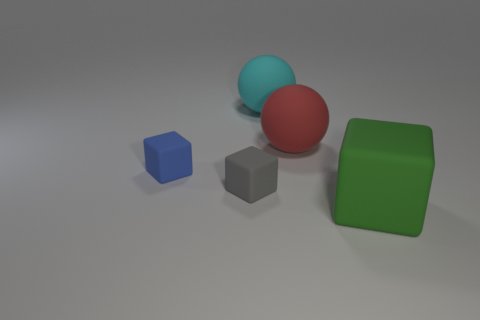What number of other things are the same size as the blue cube?
Your answer should be very brief. 1. The green matte object that is the same shape as the gray object is what size?
Give a very brief answer. Large. There is a cyan matte object that is to the right of the gray rubber cube; what shape is it?
Provide a short and direct response. Sphere. What is the color of the cube on the left side of the small matte block right of the tiny blue rubber cube?
Make the answer very short. Blue. What number of things are either objects that are on the right side of the blue matte cube or tiny red metal things?
Keep it short and to the point. 4. There is a blue rubber block; is its size the same as the rubber cube right of the large cyan matte object?
Your response must be concise. No. How many big things are either gray blocks or blue metal cylinders?
Your answer should be compact. 0. What is the shape of the tiny gray rubber object?
Keep it short and to the point. Cube. Are there any small gray objects made of the same material as the green thing?
Keep it short and to the point. Yes. Are there more spheres than gray things?
Offer a terse response. Yes. 